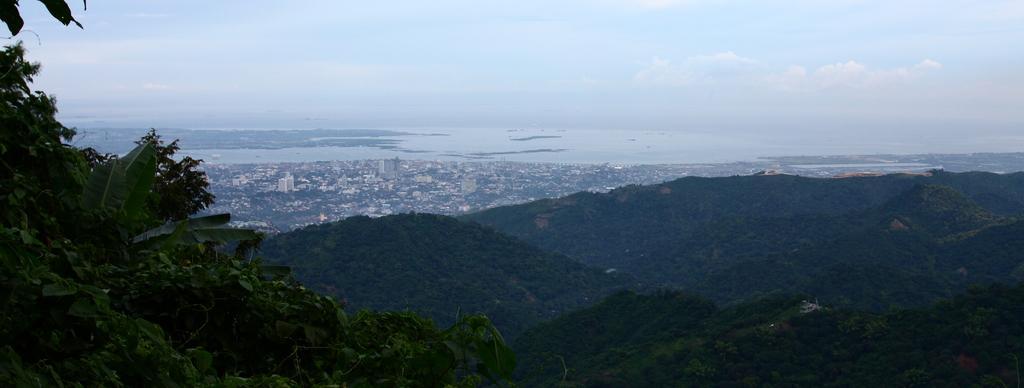Could you give a brief overview of what you see in this image? On the left side there are trees. These are the hills in the middle of an image. At the back side there is water, at the top it is the sky. 